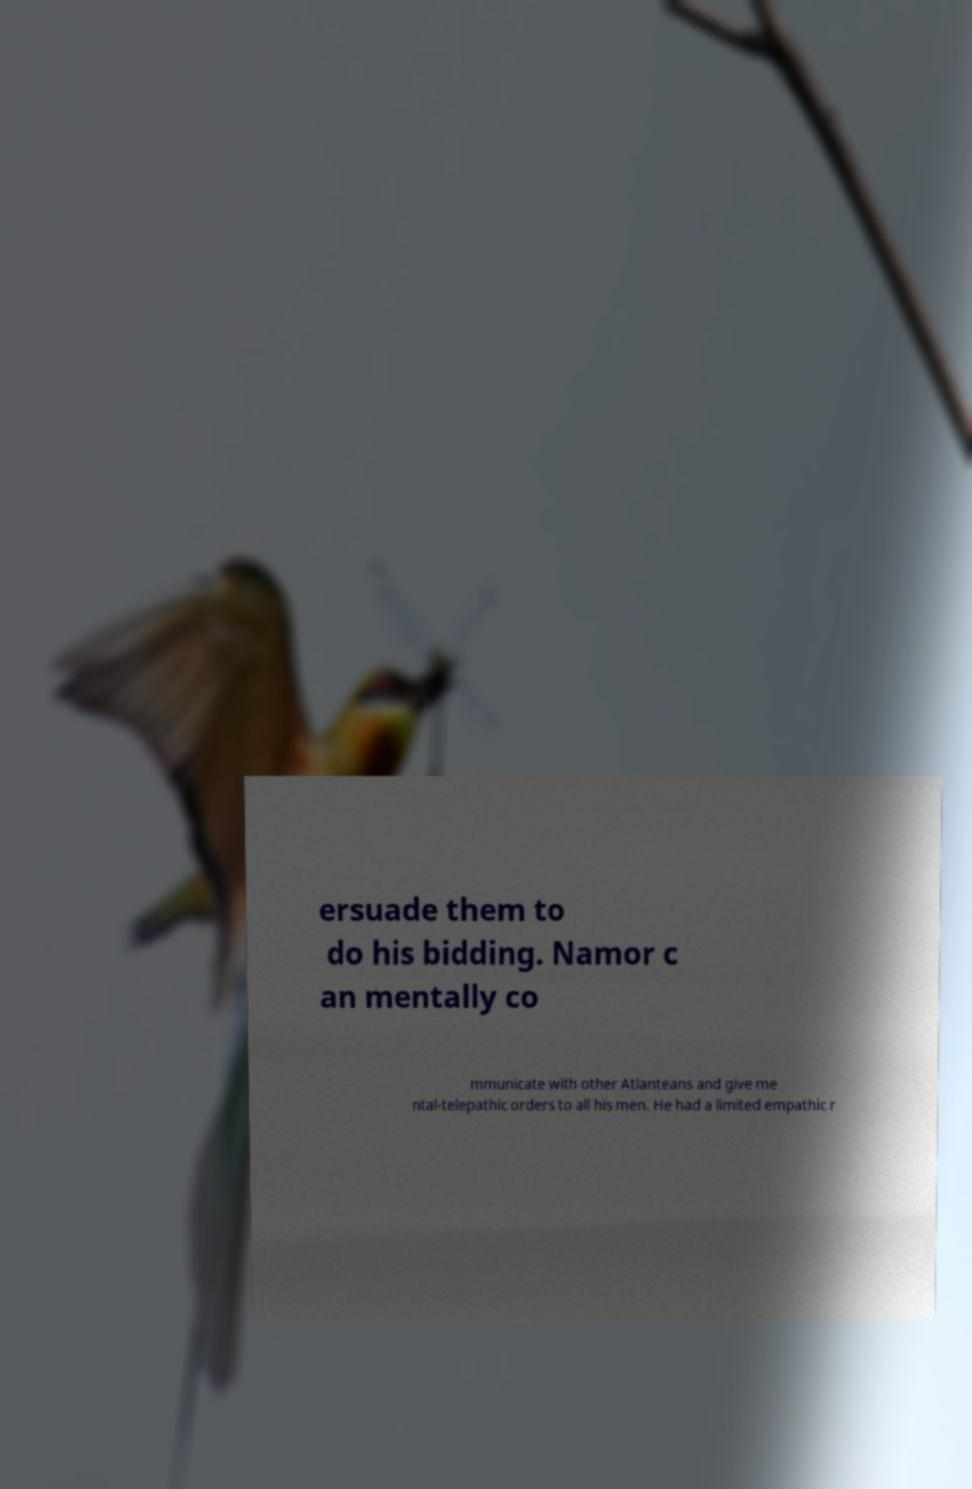Please identify and transcribe the text found in this image. ersuade them to do his bidding. Namor c an mentally co mmunicate with other Atlanteans and give me ntal-telepathic orders to all his men. He had a limited empathic r 